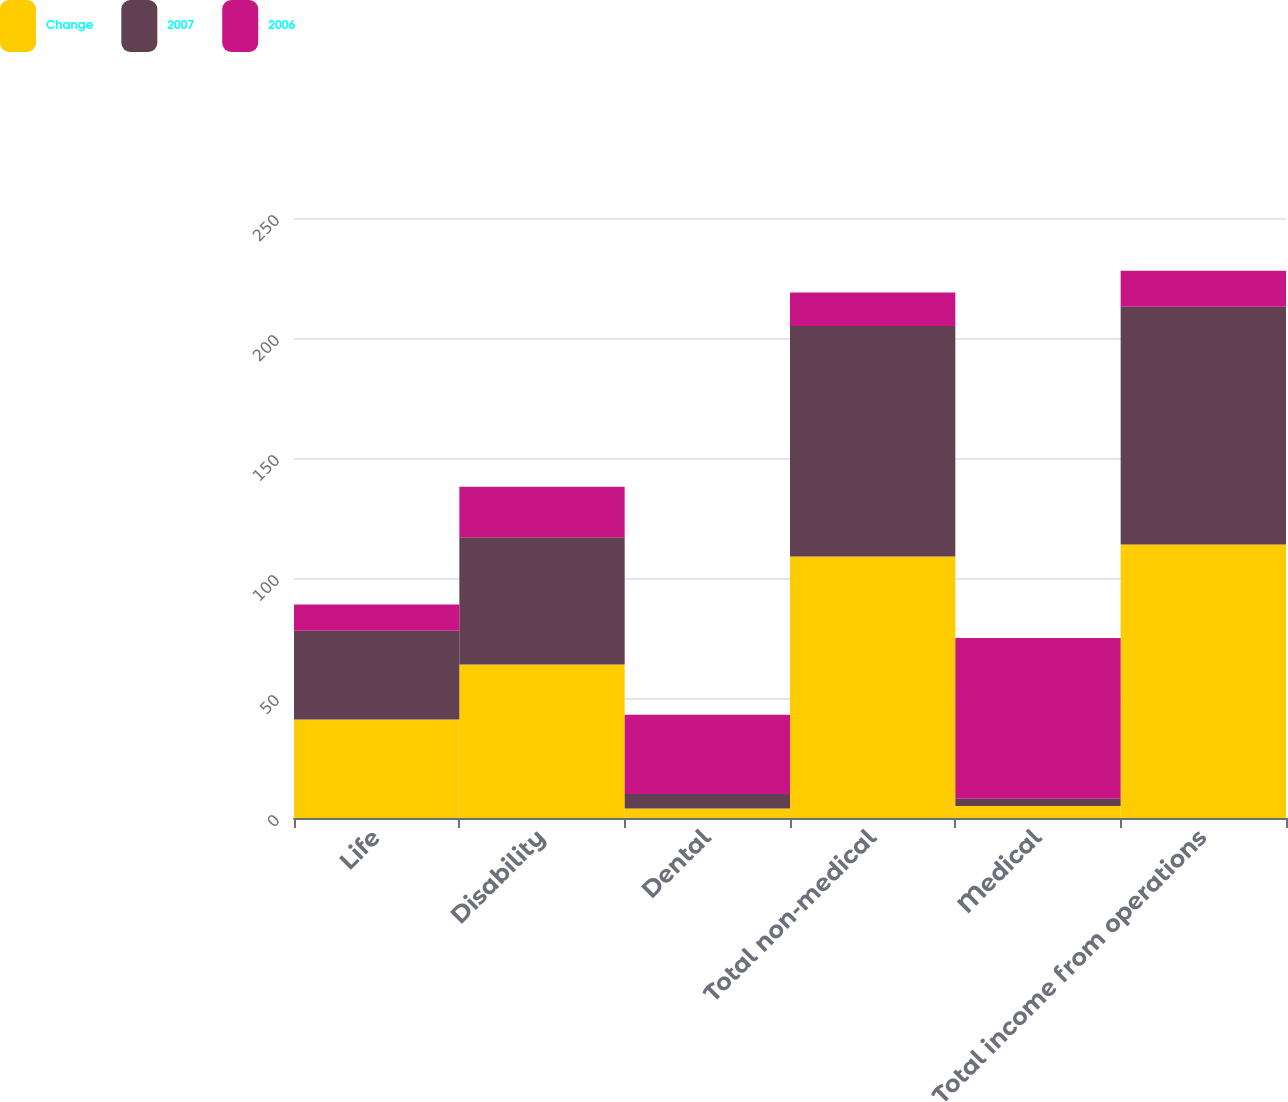Convert chart to OTSL. <chart><loc_0><loc_0><loc_500><loc_500><stacked_bar_chart><ecel><fcel>Life<fcel>Disability<fcel>Dental<fcel>Total non-medical<fcel>Medical<fcel>Total income from operations<nl><fcel>Change<fcel>41<fcel>64<fcel>4<fcel>109<fcel>5<fcel>114<nl><fcel>2007<fcel>37<fcel>53<fcel>6<fcel>96<fcel>3<fcel>99<nl><fcel>2006<fcel>11<fcel>21<fcel>33<fcel>14<fcel>67<fcel>15<nl></chart> 